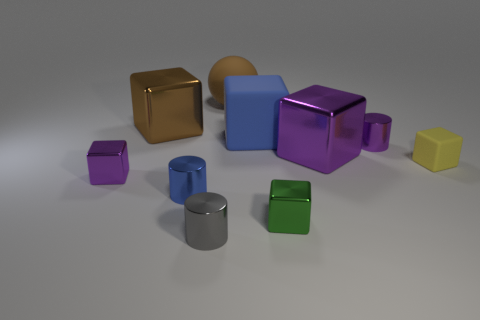There is a purple metallic block right of the brown matte ball; does it have the same size as the metallic cylinder on the left side of the small gray shiny thing?
Your answer should be compact. No. How many things are tiny blocks or large cyan shiny spheres?
Give a very brief answer. 3. What is the shape of the small blue metal thing?
Keep it short and to the point. Cylinder. There is a yellow rubber object that is the same shape as the big brown metal object; what size is it?
Ensure brevity in your answer.  Small. There is a matte cube behind the small cylinder that is right of the gray metallic cylinder; how big is it?
Ensure brevity in your answer.  Large. Is the number of small metallic things that are left of the large purple metal object the same as the number of cyan rubber cubes?
Your answer should be compact. No. How many other objects are the same color as the large rubber block?
Offer a terse response. 1. Is the number of small gray metallic cylinders that are to the right of the tiny green metallic cube less than the number of tiny brown cylinders?
Offer a very short reply. No. Is there a brown cylinder that has the same size as the yellow rubber block?
Offer a terse response. No. Is the color of the big matte cube the same as the cylinder on the left side of the gray metal cylinder?
Your response must be concise. Yes. 